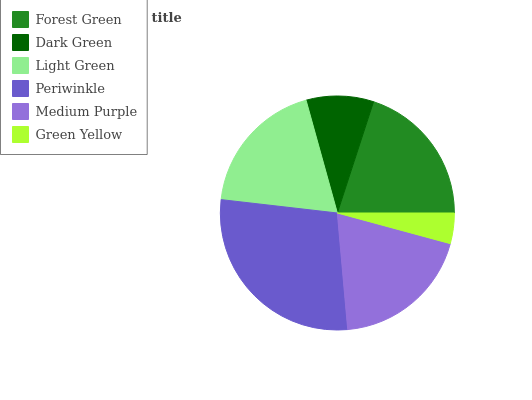Is Green Yellow the minimum?
Answer yes or no. Yes. Is Periwinkle the maximum?
Answer yes or no. Yes. Is Dark Green the minimum?
Answer yes or no. No. Is Dark Green the maximum?
Answer yes or no. No. Is Forest Green greater than Dark Green?
Answer yes or no. Yes. Is Dark Green less than Forest Green?
Answer yes or no. Yes. Is Dark Green greater than Forest Green?
Answer yes or no. No. Is Forest Green less than Dark Green?
Answer yes or no. No. Is Medium Purple the high median?
Answer yes or no. Yes. Is Light Green the low median?
Answer yes or no. Yes. Is Green Yellow the high median?
Answer yes or no. No. Is Periwinkle the low median?
Answer yes or no. No. 